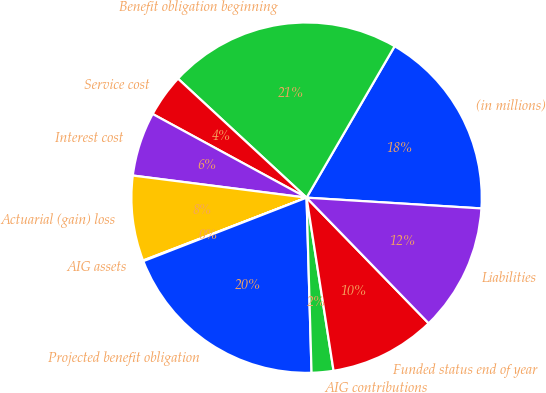Convert chart. <chart><loc_0><loc_0><loc_500><loc_500><pie_chart><fcel>(in millions)<fcel>Benefit obligation beginning<fcel>Service cost<fcel>Interest cost<fcel>Actuarial (gain) loss<fcel>AIG assets<fcel>Projected benefit obligation<fcel>AIG contributions<fcel>Funded status end of year<fcel>Liabilities<nl><fcel>17.6%<fcel>21.5%<fcel>3.96%<fcel>5.91%<fcel>7.86%<fcel>0.06%<fcel>19.55%<fcel>2.01%<fcel>9.81%<fcel>11.75%<nl></chart> 